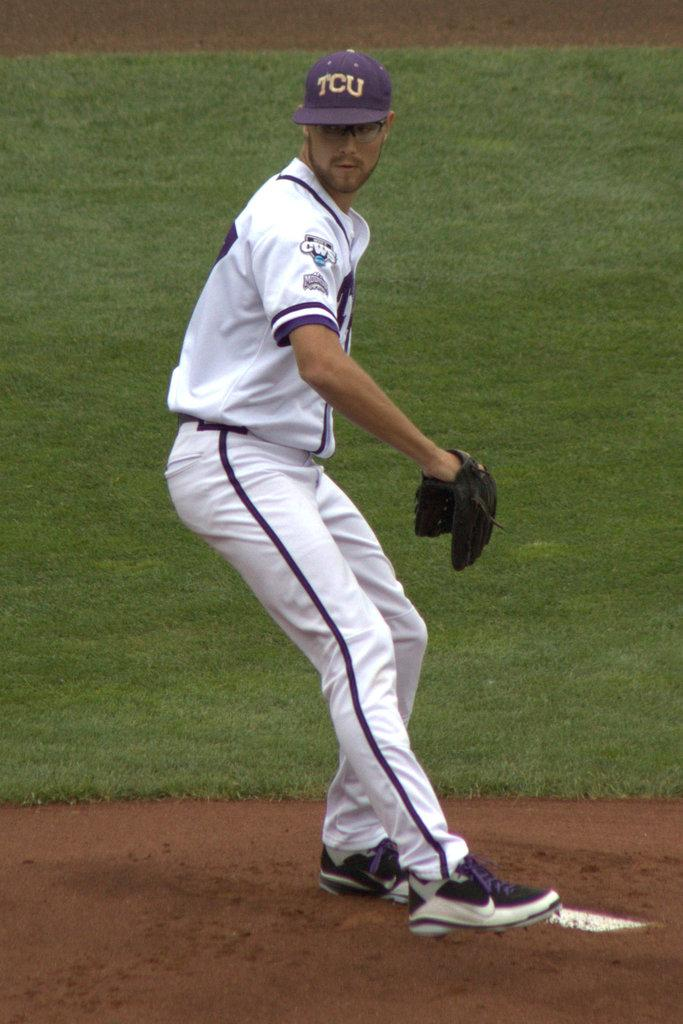<image>
Present a compact description of the photo's key features. a baseball player wearing a purple cap that says 'tcu' 